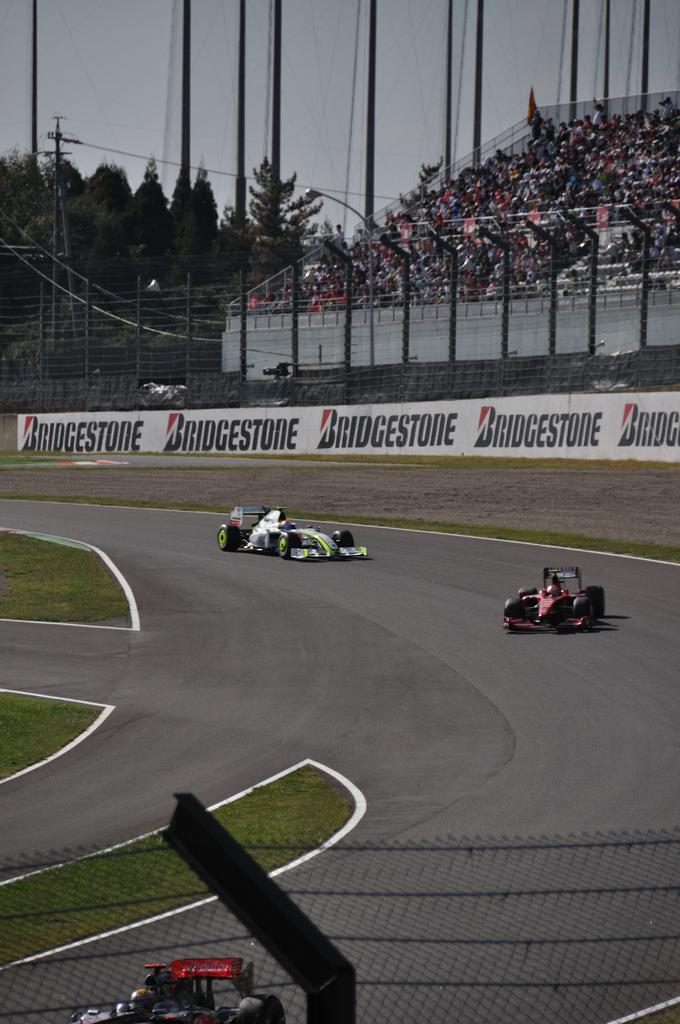What type of vehicles can be seen on the road in the image? There are sports cars on the road in the image. What type of vegetation is visible in the image? There is grass visible in the image. What type of barrier is present in the image? There is a fence in the image. What type of people are present in the image? There is a crowd in the image. What type of infrastructure is present in the image? There are poles with wires in the image. What type of natural elements are visible in the image? There are trees in the image. What part of the natural environment is visible in the image? The sky is visible in the image. How many cents are visible in the image? There are no cents present in the image. What type of respect is shown by the crowd in the image? There is no indication of respect being shown by the crowd in the image. 